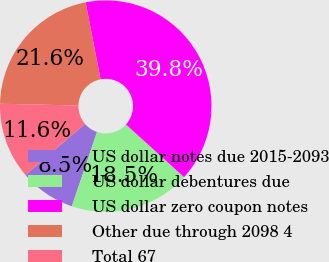<chart> <loc_0><loc_0><loc_500><loc_500><pie_chart><fcel>US dollar notes due 2015-2093<fcel>US dollar debentures due<fcel>US dollar zero coupon notes<fcel>Other due through 2098 4<fcel>Total 67<nl><fcel>8.52%<fcel>18.47%<fcel>39.77%<fcel>21.59%<fcel>11.65%<nl></chart> 